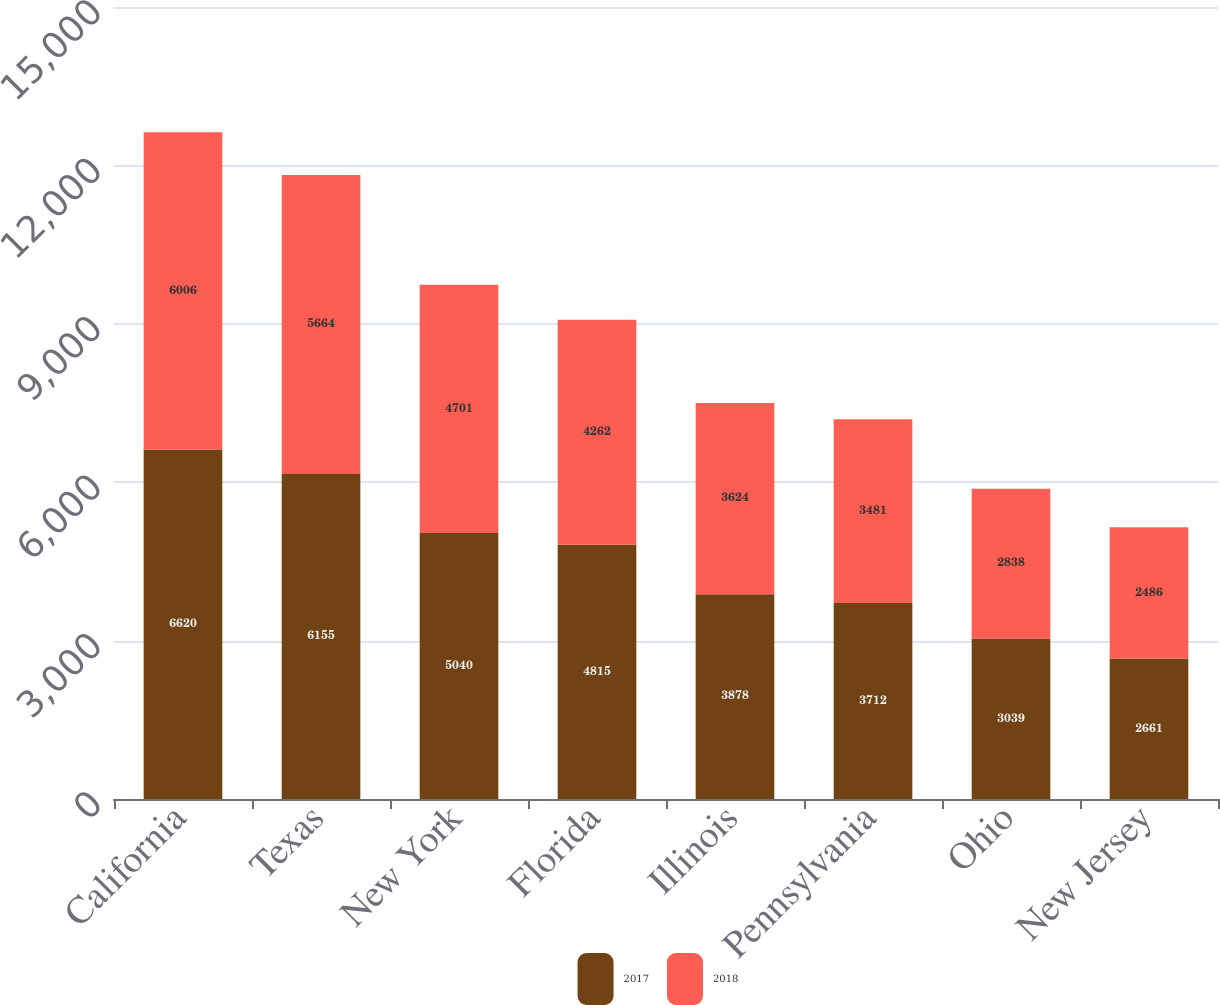Convert chart. <chart><loc_0><loc_0><loc_500><loc_500><stacked_bar_chart><ecel><fcel>California<fcel>Texas<fcel>New York<fcel>Florida<fcel>Illinois<fcel>Pennsylvania<fcel>Ohio<fcel>New Jersey<nl><fcel>2017<fcel>6620<fcel>6155<fcel>5040<fcel>4815<fcel>3878<fcel>3712<fcel>3039<fcel>2661<nl><fcel>2018<fcel>6006<fcel>5664<fcel>4701<fcel>4262<fcel>3624<fcel>3481<fcel>2838<fcel>2486<nl></chart> 